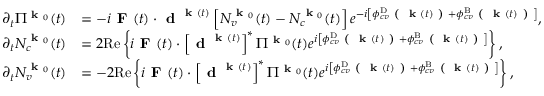<formula> <loc_0><loc_0><loc_500><loc_500>\begin{array} { r l } { \partial _ { t } \Pi ^ { k _ { 0 } } ( t ) } & { = - i F ( t ) \cdot d ^ { k ( t ) } \left [ N _ { v } ^ { k _ { 0 } } ( t ) - N _ { c } ^ { k _ { 0 } } ( t ) \right ] e ^ { - i \left [ \phi _ { c v } ^ { D } ( k ( t ) ) + \phi _ { c v } ^ { B } ( k ( t ) ) \right ] } , } \\ { \partial _ { t } N _ { c } ^ { k _ { 0 } } ( t ) } & { = 2 R e \left \{ i F ( t ) \cdot \left [ d ^ { k ( t ) } \right ] ^ { * } \Pi ^ { k _ { 0 } } ( t ) e ^ { i \left [ \phi _ { c v } ^ { D } ( k ( t ) ) + \phi _ { c v } ^ { B } ( k ( t ) ) \right ] } \right \} , } \\ { \partial _ { t } N _ { v } ^ { k _ { 0 } } ( t ) } & { = - 2 R e \left \{ i F ( t ) \cdot \left [ d ^ { k ( t ) } \right ] ^ { * } \Pi ^ { k _ { 0 } } ( t ) e ^ { i \left [ \phi _ { c v } ^ { D } ( k ( t ) ) + \phi _ { c v } ^ { B } ( k ( t ) ) \right ] } \right \} , } \end{array}</formula> 